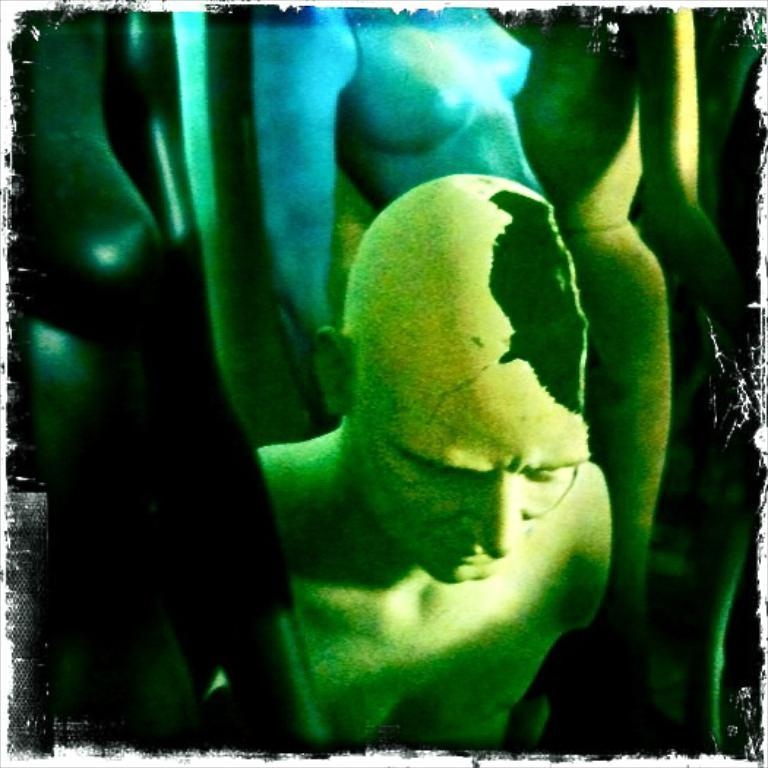How has the image been altered? The image is edited. What colors are the people in the image? There is a green color person and a blue color person in the image. What color is present on the left side of the image? There is black color on the left side of the image. What type of pump can be seen in the image? There is no pump present in the image. Is there a can visible in the image? There is no can present in the image. Can you see a cat in the image? There is no cat present in the image. 